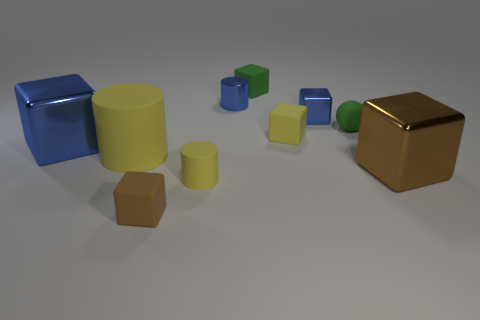Is the small brown rubber thing the same shape as the big brown metallic thing?
Offer a very short reply. Yes. How many things are either tiny cubes that are behind the blue metal cylinder or small gray shiny blocks?
Make the answer very short. 1. Is the number of small cylinders that are in front of the tiny brown matte cube the same as the number of small green spheres that are in front of the large brown shiny thing?
Ensure brevity in your answer.  Yes. How many other objects are the same shape as the large yellow object?
Provide a short and direct response. 2. There is a blue shiny thing that is left of the small blue cylinder; does it have the same size as the yellow cylinder in front of the large brown object?
Your answer should be compact. No. How many spheres are either small yellow objects or tiny blue objects?
Your answer should be compact. 0. How many matte objects are yellow objects or spheres?
Offer a very short reply. 4. What size is the other brown object that is the same shape as the tiny brown object?
Make the answer very short. Large. Does the yellow cube have the same size as the green ball to the left of the big brown metallic thing?
Provide a short and direct response. Yes. What is the shape of the green rubber thing that is behind the blue metal cylinder?
Your answer should be compact. Cube. 